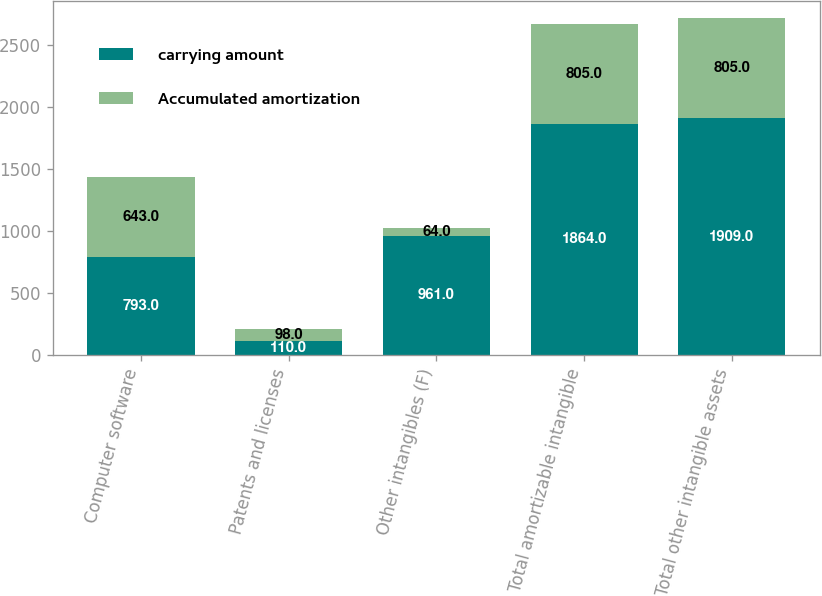Convert chart. <chart><loc_0><loc_0><loc_500><loc_500><stacked_bar_chart><ecel><fcel>Computer software<fcel>Patents and licenses<fcel>Other intangibles (F)<fcel>Total amortizable intangible<fcel>Total other intangible assets<nl><fcel>carrying amount<fcel>793<fcel>110<fcel>961<fcel>1864<fcel>1909<nl><fcel>Accumulated amortization<fcel>643<fcel>98<fcel>64<fcel>805<fcel>805<nl></chart> 